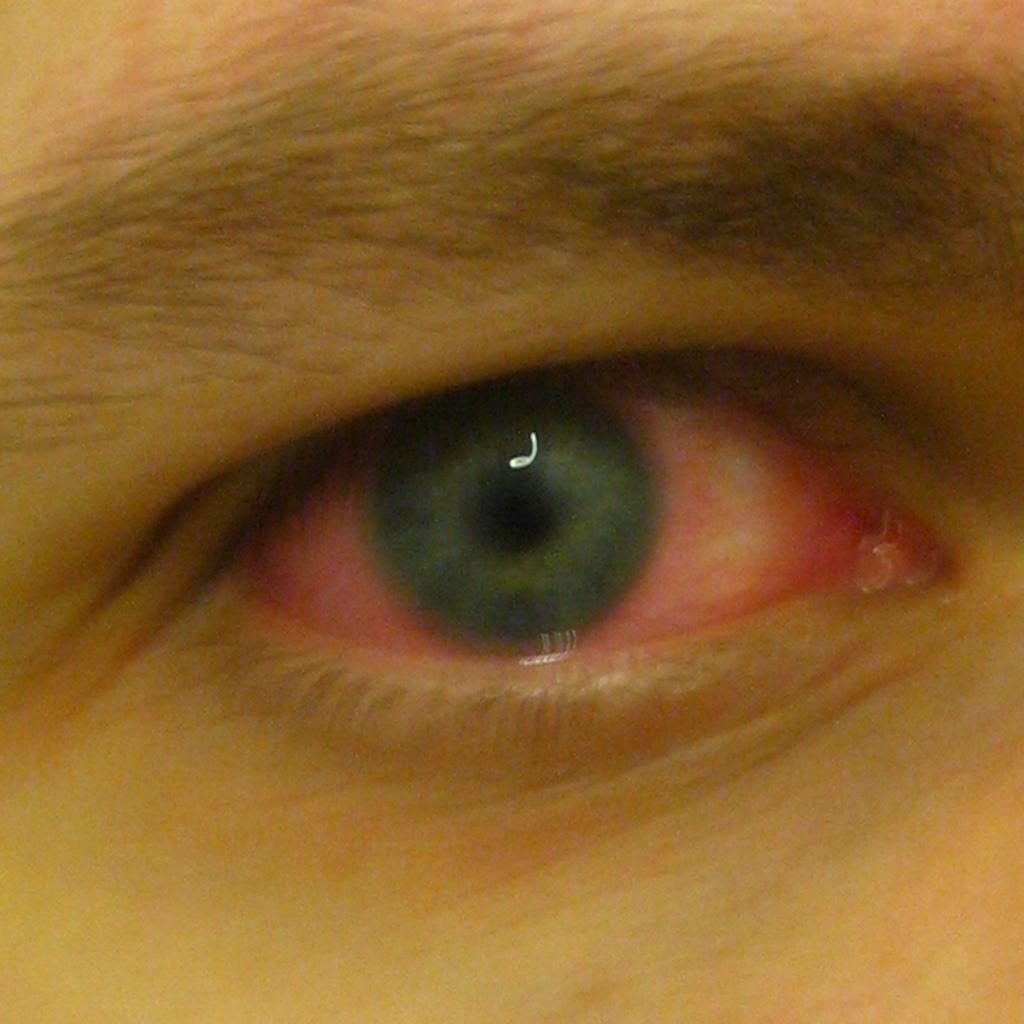Please provide a concise description of this image. In this image we can see an eye of a person. The eye is in red color. 